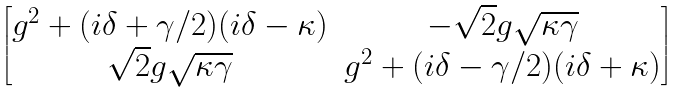<formula> <loc_0><loc_0><loc_500><loc_500>\begin{bmatrix} g ^ { 2 } + ( i \delta + \gamma / 2 ) ( i \delta - \kappa ) & - \sqrt { 2 } g \sqrt { \kappa \gamma } \\ \sqrt { 2 } g \sqrt { \kappa \gamma } & g ^ { 2 } + ( i \delta - \gamma / 2 ) ( i \delta + \kappa ) \\ \end{bmatrix}</formula> 